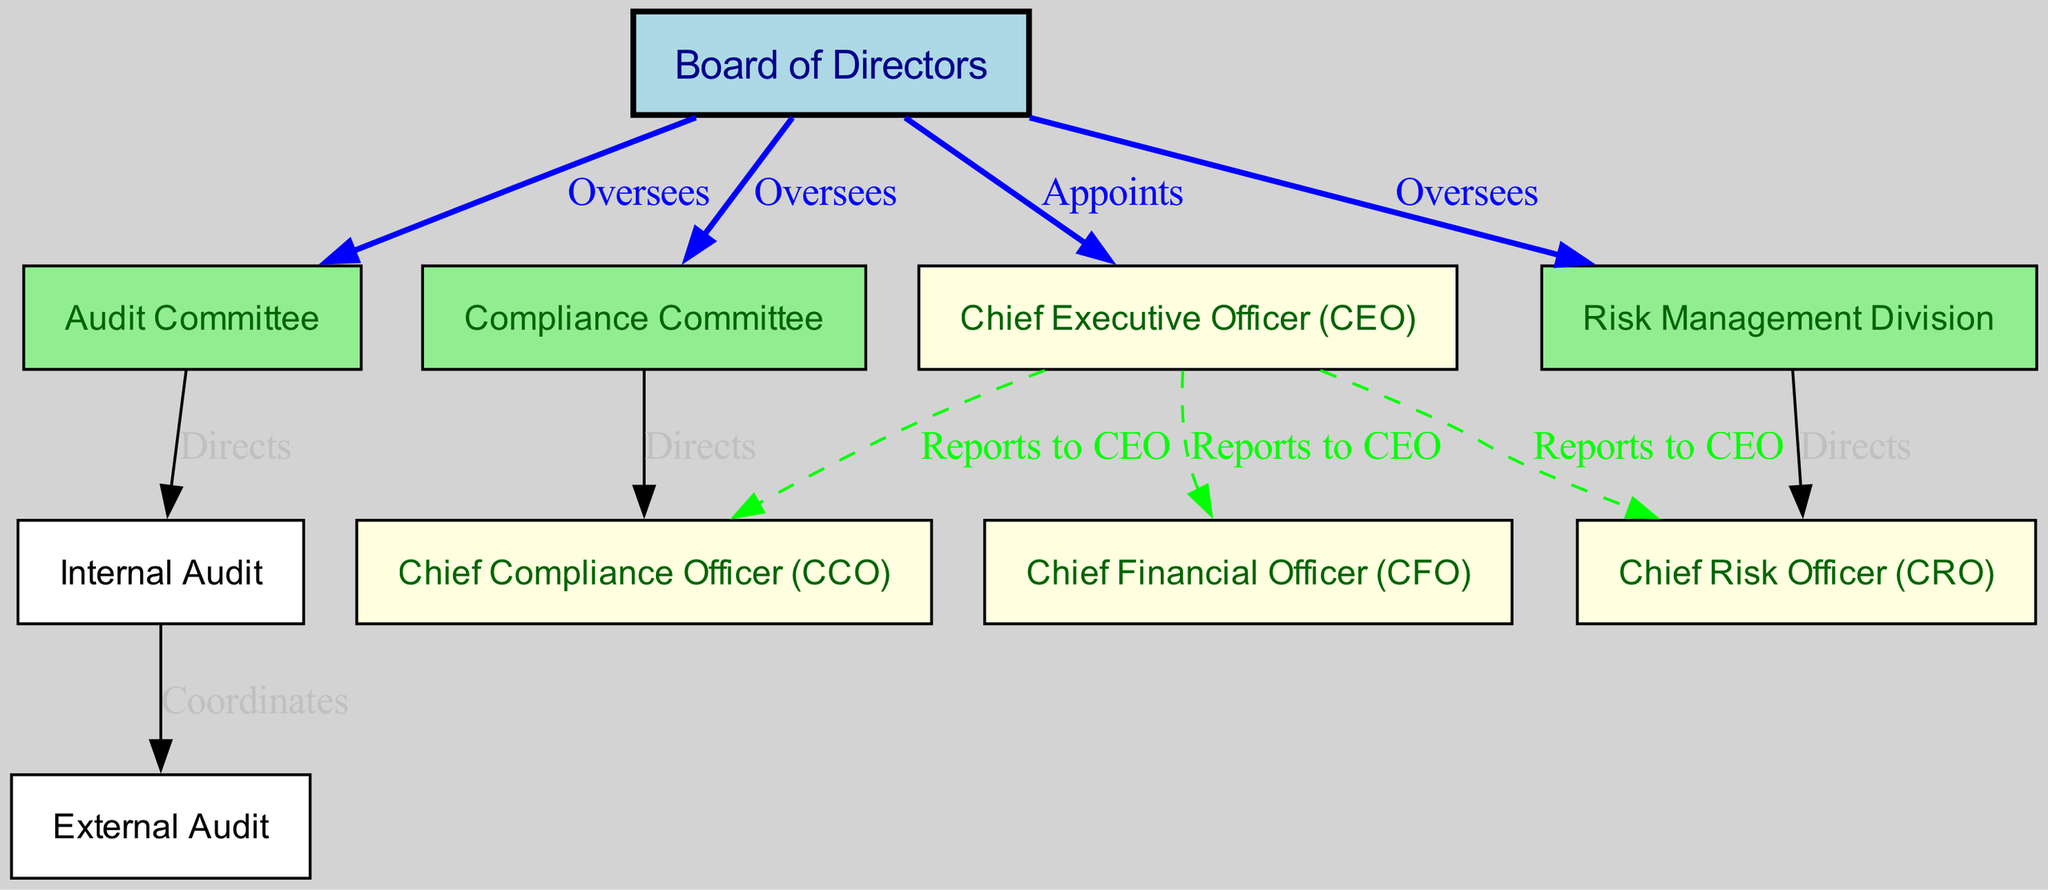What is the top node in the diagram? The top node in the hierarchy is the "Board of Directors." It is the primary governing body depicted and oversees various committees and divisions.
Answer: Board of Directors How many nodes are present in the diagram? By counting the distinct nodes listed (such as Board of Directors, CEO, Compliance Committee, etc.), there are a total of 10 nodes represented in the diagram.
Answer: 10 Who does the Audit Committee direct? The Audit Committee directs the Internal Audit, as indicated by the edge labeled "Directs" connecting these two nodes within the diagram.
Answer: Internal Audit What type of audit is coordinated by the Internal Audit? The Internal Audit coordinates with the External Audit, shown by the edge connecting these two nodes and labeled "Coordinates."
Answer: External Audit Which committee is directly overseen by the Board of Directors? The Compliance Committee, among others, is directly overseen by the Board of Directors as indicated by the line labeled "Oversees."
Answer: Compliance Committee Who reports directly to the CEO? The Chief Financial Officer (CFO), Chief Risk Officer (CRO), and Chief Compliance Officer (CCO) all report directly to the CEO, as shown by the dashed edges connecting them.
Answer: CFO, CRO, CCO Which role has a direct relationship with the Risk Management Division? The Chief Risk Officer (CRO) has a direct relationship with the Risk Management Division, as indicated by the edge labeled "Directs."
Answer: Chief Risk Officer How many edges connect the Board of Directors to other entities? The Board of Directors connects to three entities (the CEO, Compliance Committee, and Risk Management Division) through edges labeled "Appoints" and "Oversees," resulting in a total of four edges.
Answer: 4 What is the relationship between the Risk Management Division and the CRO? The relationship between these two is directional, with the Risk Management Division directing the CRO, which is shown by the labeled edge "Directs."
Answer: Directs Which node provides oversight for both Audit and Compliance? The Board of Directors provides oversight for both the Audit Committee and the Compliance Committee, as indicated by the edges labeled "Oversees" connecting to these committees.
Answer: Board of Directors 